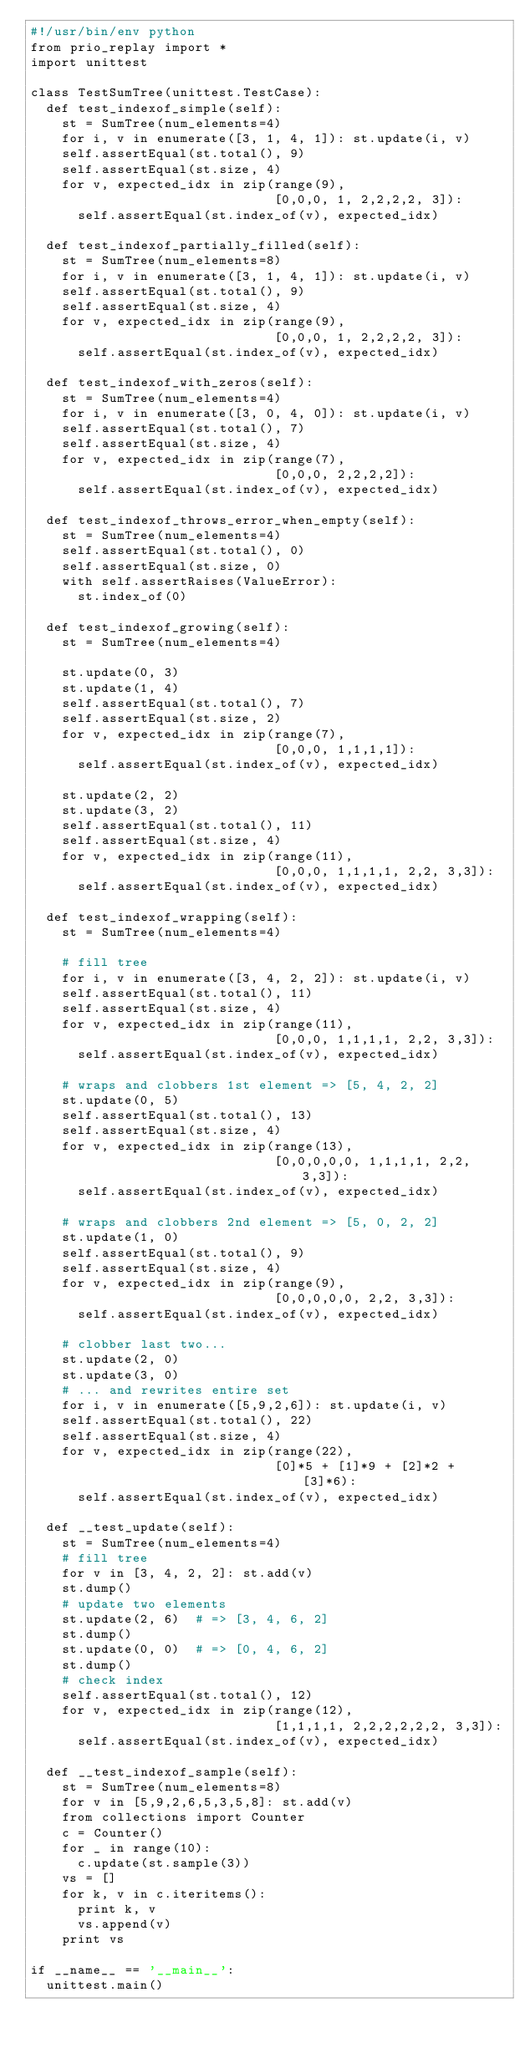<code> <loc_0><loc_0><loc_500><loc_500><_Python_>#!/usr/bin/env python
from prio_replay import *
import unittest

class TestSumTree(unittest.TestCase):
  def test_indexof_simple(self):
    st = SumTree(num_elements=4)
    for i, v in enumerate([3, 1, 4, 1]): st.update(i, v)
    self.assertEqual(st.total(), 9)
    self.assertEqual(st.size, 4)
    for v, expected_idx in zip(range(9),
                               [0,0,0, 1, 2,2,2,2, 3]):
      self.assertEqual(st.index_of(v), expected_idx)

  def test_indexof_partially_filled(self):
    st = SumTree(num_elements=8)
    for i, v in enumerate([3, 1, 4, 1]): st.update(i, v)
    self.assertEqual(st.total(), 9)
    self.assertEqual(st.size, 4)
    for v, expected_idx in zip(range(9),
                               [0,0,0, 1, 2,2,2,2, 3]):
      self.assertEqual(st.index_of(v), expected_idx)

  def test_indexof_with_zeros(self):
    st = SumTree(num_elements=4)
    for i, v in enumerate([3, 0, 4, 0]): st.update(i, v)
    self.assertEqual(st.total(), 7)
    self.assertEqual(st.size, 4)
    for v, expected_idx in zip(range(7),
                               [0,0,0, 2,2,2,2]):
      self.assertEqual(st.index_of(v), expected_idx)

  def test_indexof_throws_error_when_empty(self):
    st = SumTree(num_elements=4)
    self.assertEqual(st.total(), 0)
    self.assertEqual(st.size, 0)
    with self.assertRaises(ValueError):
      st.index_of(0)

  def test_indexof_growing(self):
    st = SumTree(num_elements=4)

    st.update(0, 3)
    st.update(1, 4)
    self.assertEqual(st.total(), 7)
    self.assertEqual(st.size, 2)
    for v, expected_idx in zip(range(7),
                               [0,0,0, 1,1,1,1]):
      self.assertEqual(st.index_of(v), expected_idx)

    st.update(2, 2)
    st.update(3, 2)
    self.assertEqual(st.total(), 11)
    self.assertEqual(st.size, 4)
    for v, expected_idx in zip(range(11),
                               [0,0,0, 1,1,1,1, 2,2, 3,3]):
      self.assertEqual(st.index_of(v), expected_idx)

  def test_indexof_wrapping(self):
    st = SumTree(num_elements=4)

    # fill tree
    for i, v in enumerate([3, 4, 2, 2]): st.update(i, v)
    self.assertEqual(st.total(), 11)
    self.assertEqual(st.size, 4)
    for v, expected_idx in zip(range(11),
                               [0,0,0, 1,1,1,1, 2,2, 3,3]):
      self.assertEqual(st.index_of(v), expected_idx)

    # wraps and clobbers 1st element => [5, 4, 2, 2]
    st.update(0, 5)
    self.assertEqual(st.total(), 13)
    self.assertEqual(st.size, 4)
    for v, expected_idx in zip(range(13),
                               [0,0,0,0,0, 1,1,1,1, 2,2, 3,3]):
      self.assertEqual(st.index_of(v), expected_idx)

    # wraps and clobbers 2nd element => [5, 0, 2, 2]
    st.update(1, 0)
    self.assertEqual(st.total(), 9)
    self.assertEqual(st.size, 4)
    for v, expected_idx in zip(range(9),
                               [0,0,0,0,0, 2,2, 3,3]):
      self.assertEqual(st.index_of(v), expected_idx)

    # clobber last two...
    st.update(2, 0)
    st.update(3, 0)
    # ... and rewrites entire set
    for i, v in enumerate([5,9,2,6]): st.update(i, v)
    self.assertEqual(st.total(), 22)
    self.assertEqual(st.size, 4)
    for v, expected_idx in zip(range(22),
                               [0]*5 + [1]*9 + [2]*2 + [3]*6):
      self.assertEqual(st.index_of(v), expected_idx)

  def __test_update(self):
    st = SumTree(num_elements=4)
    # fill tree
    for v in [3, 4, 2, 2]: st.add(v)
    st.dump()
    # update two elements
    st.update(2, 6)  # => [3, 4, 6, 2]
    st.dump()
    st.update(0, 0)  # => [0, 4, 6, 2]
    st.dump()
    # check index
    self.assertEqual(st.total(), 12)
    for v, expected_idx in zip(range(12),
                               [1,1,1,1, 2,2,2,2,2,2, 3,3]):
      self.assertEqual(st.index_of(v), expected_idx)

  def __test_indexof_sample(self):
    st = SumTree(num_elements=8)
    for v in [5,9,2,6,5,3,5,8]: st.add(v)
    from collections import Counter
    c = Counter()
    for _ in range(10):
      c.update(st.sample(3))
    vs = []
    for k, v in c.iteritems():
      print k, v
      vs.append(v)
    print vs

if __name__ == '__main__':
  unittest.main()
</code> 